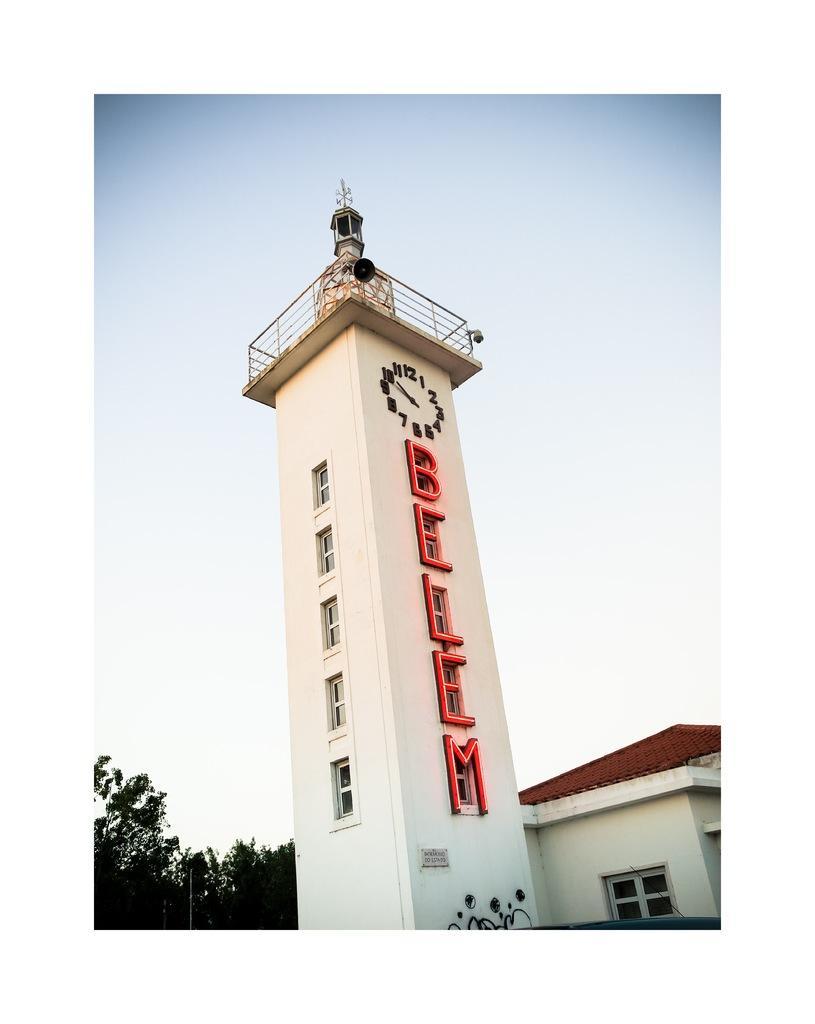Describe this image in one or two sentences. In this image we can see a tower, there is a clock, there is a led display, there are windows, beside there is a house, there is a tree, there is sky at the top. 